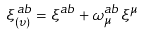<formula> <loc_0><loc_0><loc_500><loc_500>\xi _ { ( \upsilon ) } ^ { \, { a b } } = \xi ^ { a b } + \omega _ { \mu } ^ { a b } \xi ^ { \mu }</formula> 